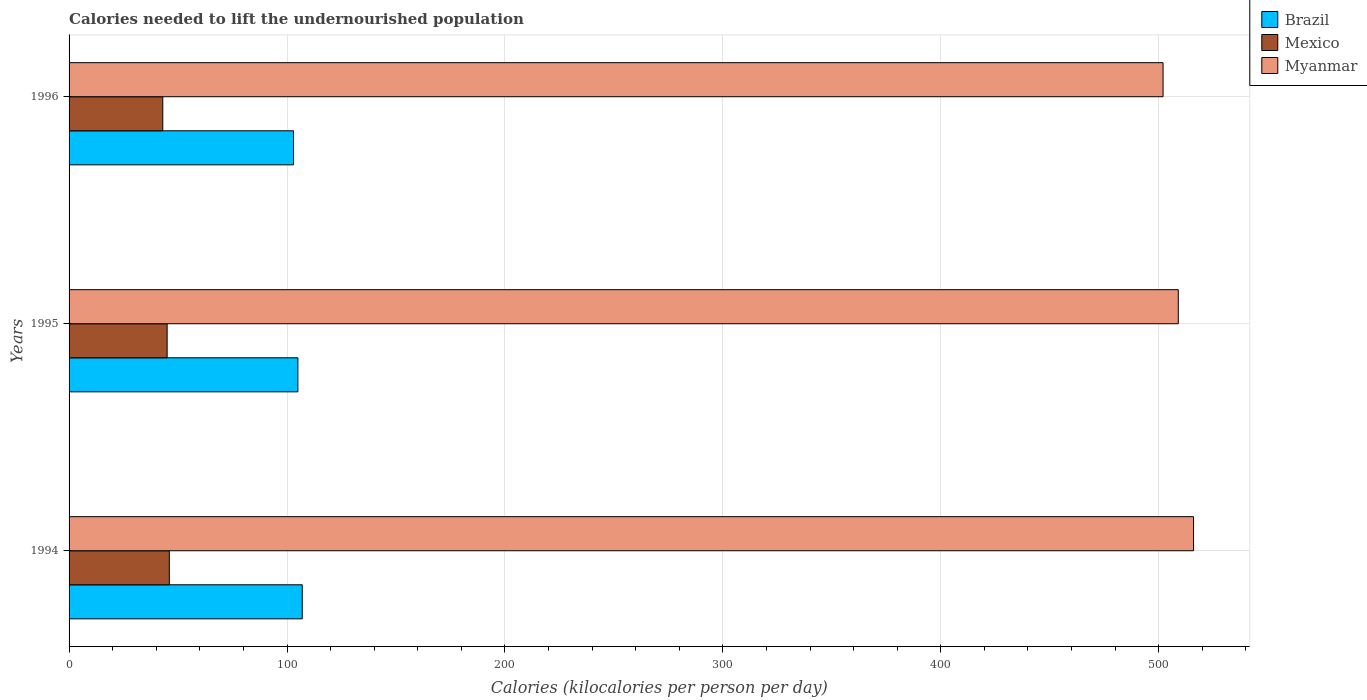How many different coloured bars are there?
Give a very brief answer. 3. Are the number of bars per tick equal to the number of legend labels?
Provide a succinct answer. Yes. Are the number of bars on each tick of the Y-axis equal?
Your answer should be very brief. Yes. How many bars are there on the 2nd tick from the top?
Provide a short and direct response. 3. How many bars are there on the 1st tick from the bottom?
Your answer should be compact. 3. What is the total calories needed to lift the undernourished population in Brazil in 1994?
Your answer should be very brief. 107. Across all years, what is the maximum total calories needed to lift the undernourished population in Mexico?
Keep it short and to the point. 46. Across all years, what is the minimum total calories needed to lift the undernourished population in Mexico?
Ensure brevity in your answer.  43. What is the total total calories needed to lift the undernourished population in Mexico in the graph?
Offer a terse response. 134. What is the difference between the total calories needed to lift the undernourished population in Mexico in 1994 and that in 1996?
Offer a very short reply. 3. What is the difference between the total calories needed to lift the undernourished population in Brazil in 1996 and the total calories needed to lift the undernourished population in Myanmar in 1995?
Your answer should be very brief. -406. What is the average total calories needed to lift the undernourished population in Mexico per year?
Your answer should be very brief. 44.67. In the year 1996, what is the difference between the total calories needed to lift the undernourished population in Mexico and total calories needed to lift the undernourished population in Myanmar?
Offer a terse response. -459. What is the ratio of the total calories needed to lift the undernourished population in Myanmar in 1994 to that in 1995?
Give a very brief answer. 1.01. Is the total calories needed to lift the undernourished population in Brazil in 1995 less than that in 1996?
Your answer should be very brief. No. Is the difference between the total calories needed to lift the undernourished population in Mexico in 1994 and 1995 greater than the difference between the total calories needed to lift the undernourished population in Myanmar in 1994 and 1995?
Your answer should be compact. No. What is the difference between the highest and the lowest total calories needed to lift the undernourished population in Mexico?
Your answer should be very brief. 3. What does the 1st bar from the bottom in 1995 represents?
Your answer should be very brief. Brazil. Are all the bars in the graph horizontal?
Give a very brief answer. Yes. How many years are there in the graph?
Make the answer very short. 3. What is the difference between two consecutive major ticks on the X-axis?
Your answer should be very brief. 100. Are the values on the major ticks of X-axis written in scientific E-notation?
Make the answer very short. No. Does the graph contain any zero values?
Offer a very short reply. No. Does the graph contain grids?
Make the answer very short. Yes. How are the legend labels stacked?
Offer a very short reply. Vertical. What is the title of the graph?
Your answer should be compact. Calories needed to lift the undernourished population. Does "Egypt, Arab Rep." appear as one of the legend labels in the graph?
Your response must be concise. No. What is the label or title of the X-axis?
Provide a succinct answer. Calories (kilocalories per person per day). What is the label or title of the Y-axis?
Offer a very short reply. Years. What is the Calories (kilocalories per person per day) in Brazil in 1994?
Your answer should be very brief. 107. What is the Calories (kilocalories per person per day) of Myanmar in 1994?
Your answer should be very brief. 516. What is the Calories (kilocalories per person per day) in Brazil in 1995?
Keep it short and to the point. 105. What is the Calories (kilocalories per person per day) in Myanmar in 1995?
Keep it short and to the point. 509. What is the Calories (kilocalories per person per day) in Brazil in 1996?
Give a very brief answer. 103. What is the Calories (kilocalories per person per day) in Mexico in 1996?
Make the answer very short. 43. What is the Calories (kilocalories per person per day) of Myanmar in 1996?
Your answer should be compact. 502. Across all years, what is the maximum Calories (kilocalories per person per day) of Brazil?
Give a very brief answer. 107. Across all years, what is the maximum Calories (kilocalories per person per day) of Myanmar?
Your answer should be compact. 516. Across all years, what is the minimum Calories (kilocalories per person per day) in Brazil?
Provide a short and direct response. 103. Across all years, what is the minimum Calories (kilocalories per person per day) of Mexico?
Offer a terse response. 43. Across all years, what is the minimum Calories (kilocalories per person per day) of Myanmar?
Provide a succinct answer. 502. What is the total Calories (kilocalories per person per day) in Brazil in the graph?
Make the answer very short. 315. What is the total Calories (kilocalories per person per day) of Mexico in the graph?
Make the answer very short. 134. What is the total Calories (kilocalories per person per day) of Myanmar in the graph?
Ensure brevity in your answer.  1527. What is the difference between the Calories (kilocalories per person per day) in Brazil in 1994 and that in 1995?
Make the answer very short. 2. What is the difference between the Calories (kilocalories per person per day) in Myanmar in 1994 and that in 1995?
Provide a short and direct response. 7. What is the difference between the Calories (kilocalories per person per day) of Brazil in 1995 and that in 1996?
Give a very brief answer. 2. What is the difference between the Calories (kilocalories per person per day) of Mexico in 1995 and that in 1996?
Provide a succinct answer. 2. What is the difference between the Calories (kilocalories per person per day) in Myanmar in 1995 and that in 1996?
Make the answer very short. 7. What is the difference between the Calories (kilocalories per person per day) in Brazil in 1994 and the Calories (kilocalories per person per day) in Mexico in 1995?
Make the answer very short. 62. What is the difference between the Calories (kilocalories per person per day) of Brazil in 1994 and the Calories (kilocalories per person per day) of Myanmar in 1995?
Keep it short and to the point. -402. What is the difference between the Calories (kilocalories per person per day) in Mexico in 1994 and the Calories (kilocalories per person per day) in Myanmar in 1995?
Offer a terse response. -463. What is the difference between the Calories (kilocalories per person per day) of Brazil in 1994 and the Calories (kilocalories per person per day) of Myanmar in 1996?
Your answer should be compact. -395. What is the difference between the Calories (kilocalories per person per day) in Mexico in 1994 and the Calories (kilocalories per person per day) in Myanmar in 1996?
Your answer should be very brief. -456. What is the difference between the Calories (kilocalories per person per day) in Brazil in 1995 and the Calories (kilocalories per person per day) in Myanmar in 1996?
Your answer should be very brief. -397. What is the difference between the Calories (kilocalories per person per day) of Mexico in 1995 and the Calories (kilocalories per person per day) of Myanmar in 1996?
Offer a terse response. -457. What is the average Calories (kilocalories per person per day) in Brazil per year?
Keep it short and to the point. 105. What is the average Calories (kilocalories per person per day) in Mexico per year?
Ensure brevity in your answer.  44.67. What is the average Calories (kilocalories per person per day) of Myanmar per year?
Provide a succinct answer. 509. In the year 1994, what is the difference between the Calories (kilocalories per person per day) in Brazil and Calories (kilocalories per person per day) in Myanmar?
Your response must be concise. -409. In the year 1994, what is the difference between the Calories (kilocalories per person per day) of Mexico and Calories (kilocalories per person per day) of Myanmar?
Your response must be concise. -470. In the year 1995, what is the difference between the Calories (kilocalories per person per day) of Brazil and Calories (kilocalories per person per day) of Myanmar?
Make the answer very short. -404. In the year 1995, what is the difference between the Calories (kilocalories per person per day) of Mexico and Calories (kilocalories per person per day) of Myanmar?
Offer a very short reply. -464. In the year 1996, what is the difference between the Calories (kilocalories per person per day) in Brazil and Calories (kilocalories per person per day) in Mexico?
Offer a terse response. 60. In the year 1996, what is the difference between the Calories (kilocalories per person per day) in Brazil and Calories (kilocalories per person per day) in Myanmar?
Provide a short and direct response. -399. In the year 1996, what is the difference between the Calories (kilocalories per person per day) of Mexico and Calories (kilocalories per person per day) of Myanmar?
Your response must be concise. -459. What is the ratio of the Calories (kilocalories per person per day) in Mexico in 1994 to that in 1995?
Your response must be concise. 1.02. What is the ratio of the Calories (kilocalories per person per day) of Myanmar in 1994 to that in 1995?
Make the answer very short. 1.01. What is the ratio of the Calories (kilocalories per person per day) in Brazil in 1994 to that in 1996?
Keep it short and to the point. 1.04. What is the ratio of the Calories (kilocalories per person per day) of Mexico in 1994 to that in 1996?
Keep it short and to the point. 1.07. What is the ratio of the Calories (kilocalories per person per day) of Myanmar in 1994 to that in 1996?
Provide a succinct answer. 1.03. What is the ratio of the Calories (kilocalories per person per day) in Brazil in 1995 to that in 1996?
Make the answer very short. 1.02. What is the ratio of the Calories (kilocalories per person per day) of Mexico in 1995 to that in 1996?
Give a very brief answer. 1.05. What is the ratio of the Calories (kilocalories per person per day) of Myanmar in 1995 to that in 1996?
Give a very brief answer. 1.01. What is the difference between the highest and the second highest Calories (kilocalories per person per day) in Brazil?
Offer a terse response. 2. What is the difference between the highest and the lowest Calories (kilocalories per person per day) in Mexico?
Make the answer very short. 3. 